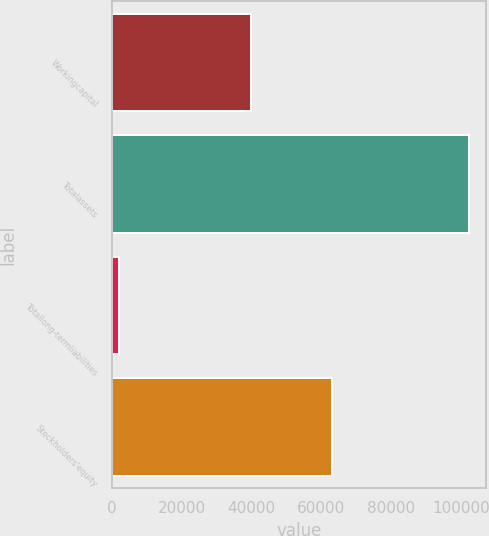<chart> <loc_0><loc_0><loc_500><loc_500><bar_chart><fcel>Workingcapital<fcel>Totalassets<fcel>Totallong-termliabilities<fcel>Stockholders'equity<nl><fcel>39737<fcel>102202<fcel>1849<fcel>62976<nl></chart> 